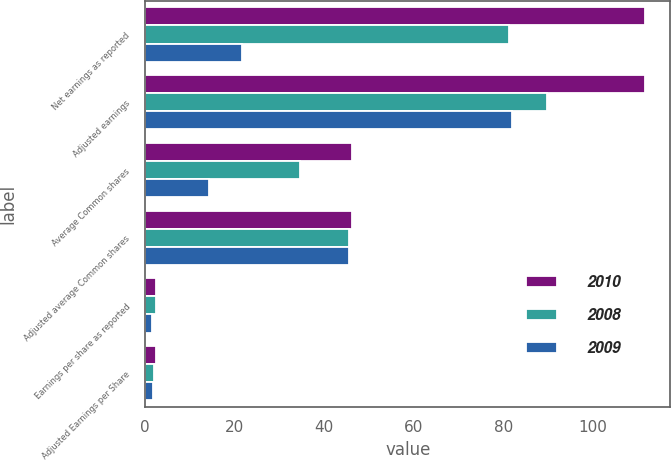<chart> <loc_0><loc_0><loc_500><loc_500><stacked_bar_chart><ecel><fcel>Net earnings as reported<fcel>Adjusted earnings<fcel>Average Common shares<fcel>Adjusted average Common shares<fcel>Earnings per share as reported<fcel>Adjusted Earnings per Share<nl><fcel>2010<fcel>111.7<fcel>111.7<fcel>46.2<fcel>46.2<fcel>2.42<fcel>2.42<nl><fcel>2008<fcel>81.3<fcel>89.7<fcel>34.5<fcel>45.5<fcel>2.36<fcel>1.97<nl><fcel>2009<fcel>21.7<fcel>81.9<fcel>14.2<fcel>45.4<fcel>1.53<fcel>1.8<nl></chart> 